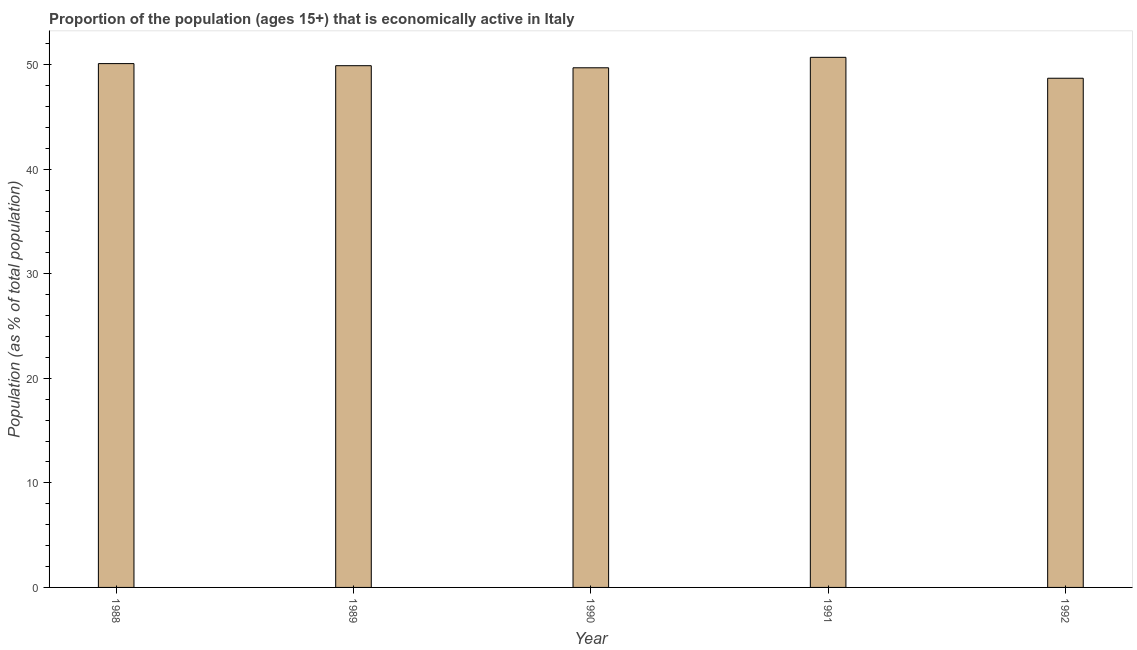Does the graph contain any zero values?
Your answer should be compact. No. What is the title of the graph?
Give a very brief answer. Proportion of the population (ages 15+) that is economically active in Italy. What is the label or title of the X-axis?
Offer a terse response. Year. What is the label or title of the Y-axis?
Provide a short and direct response. Population (as % of total population). What is the percentage of economically active population in 1992?
Provide a succinct answer. 48.7. Across all years, what is the maximum percentage of economically active population?
Your answer should be very brief. 50.7. Across all years, what is the minimum percentage of economically active population?
Offer a very short reply. 48.7. In which year was the percentage of economically active population maximum?
Provide a short and direct response. 1991. What is the sum of the percentage of economically active population?
Provide a short and direct response. 249.1. What is the difference between the percentage of economically active population in 1990 and 1991?
Provide a short and direct response. -1. What is the average percentage of economically active population per year?
Offer a very short reply. 49.82. What is the median percentage of economically active population?
Your response must be concise. 49.9. Do a majority of the years between 1990 and 1992 (inclusive) have percentage of economically active population greater than 24 %?
Offer a terse response. Yes. Is the percentage of economically active population in 1988 less than that in 1991?
Your response must be concise. Yes. Is the difference between the percentage of economically active population in 1989 and 1992 greater than the difference between any two years?
Your answer should be compact. No. Is the sum of the percentage of economically active population in 1990 and 1992 greater than the maximum percentage of economically active population across all years?
Provide a short and direct response. Yes. What is the difference between the highest and the lowest percentage of economically active population?
Make the answer very short. 2. In how many years, is the percentage of economically active population greater than the average percentage of economically active population taken over all years?
Provide a succinct answer. 3. How many bars are there?
Keep it short and to the point. 5. How many years are there in the graph?
Give a very brief answer. 5. What is the difference between two consecutive major ticks on the Y-axis?
Offer a very short reply. 10. Are the values on the major ticks of Y-axis written in scientific E-notation?
Keep it short and to the point. No. What is the Population (as % of total population) of 1988?
Your answer should be compact. 50.1. What is the Population (as % of total population) in 1989?
Offer a terse response. 49.9. What is the Population (as % of total population) in 1990?
Your response must be concise. 49.7. What is the Population (as % of total population) in 1991?
Give a very brief answer. 50.7. What is the Population (as % of total population) of 1992?
Your answer should be very brief. 48.7. What is the difference between the Population (as % of total population) in 1988 and 1992?
Give a very brief answer. 1.4. What is the difference between the Population (as % of total population) in 1990 and 1992?
Keep it short and to the point. 1. What is the ratio of the Population (as % of total population) in 1988 to that in 1990?
Provide a short and direct response. 1.01. What is the ratio of the Population (as % of total population) in 1988 to that in 1991?
Provide a short and direct response. 0.99. What is the ratio of the Population (as % of total population) in 1989 to that in 1990?
Offer a terse response. 1. What is the ratio of the Population (as % of total population) in 1989 to that in 1992?
Your answer should be very brief. 1.02. What is the ratio of the Population (as % of total population) in 1991 to that in 1992?
Your answer should be very brief. 1.04. 